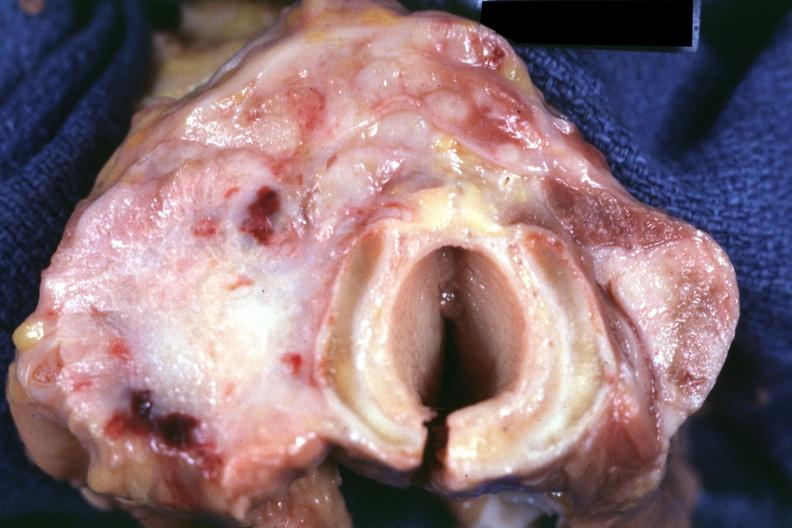what is 70yof had?
Answer the question using a single word or phrase. Colon carcinoma 